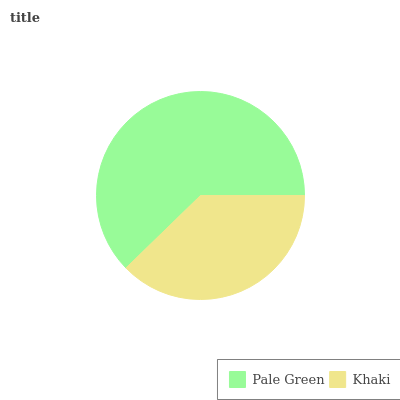Is Khaki the minimum?
Answer yes or no. Yes. Is Pale Green the maximum?
Answer yes or no. Yes. Is Khaki the maximum?
Answer yes or no. No. Is Pale Green greater than Khaki?
Answer yes or no. Yes. Is Khaki less than Pale Green?
Answer yes or no. Yes. Is Khaki greater than Pale Green?
Answer yes or no. No. Is Pale Green less than Khaki?
Answer yes or no. No. Is Pale Green the high median?
Answer yes or no. Yes. Is Khaki the low median?
Answer yes or no. Yes. Is Khaki the high median?
Answer yes or no. No. Is Pale Green the low median?
Answer yes or no. No. 